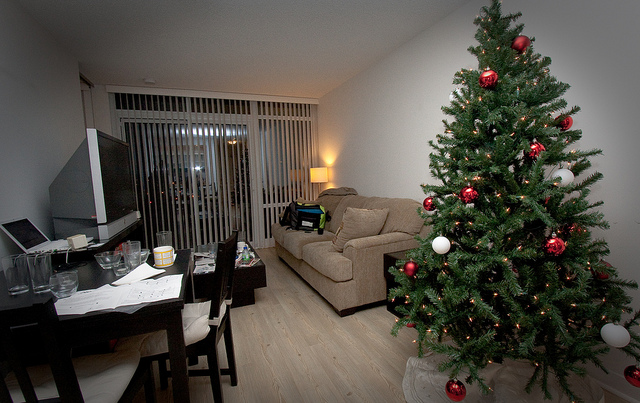Describe the atmosphere of the room? The room has a cozy and festive atmosphere, with a Christmas tree lit by a string of white lights offering a warm ambience. The rest of the room is dimly lit, which emphasizes the holiday decor and makes the space inviting. Can you tell me if this place is kept in an orderly manner? The room appears lived-in and functional with items on the dining table suggesting recent use. There's a sense of daily life occurring here, which is not strictly orderly but reflects a personal and practical usage of the space. 